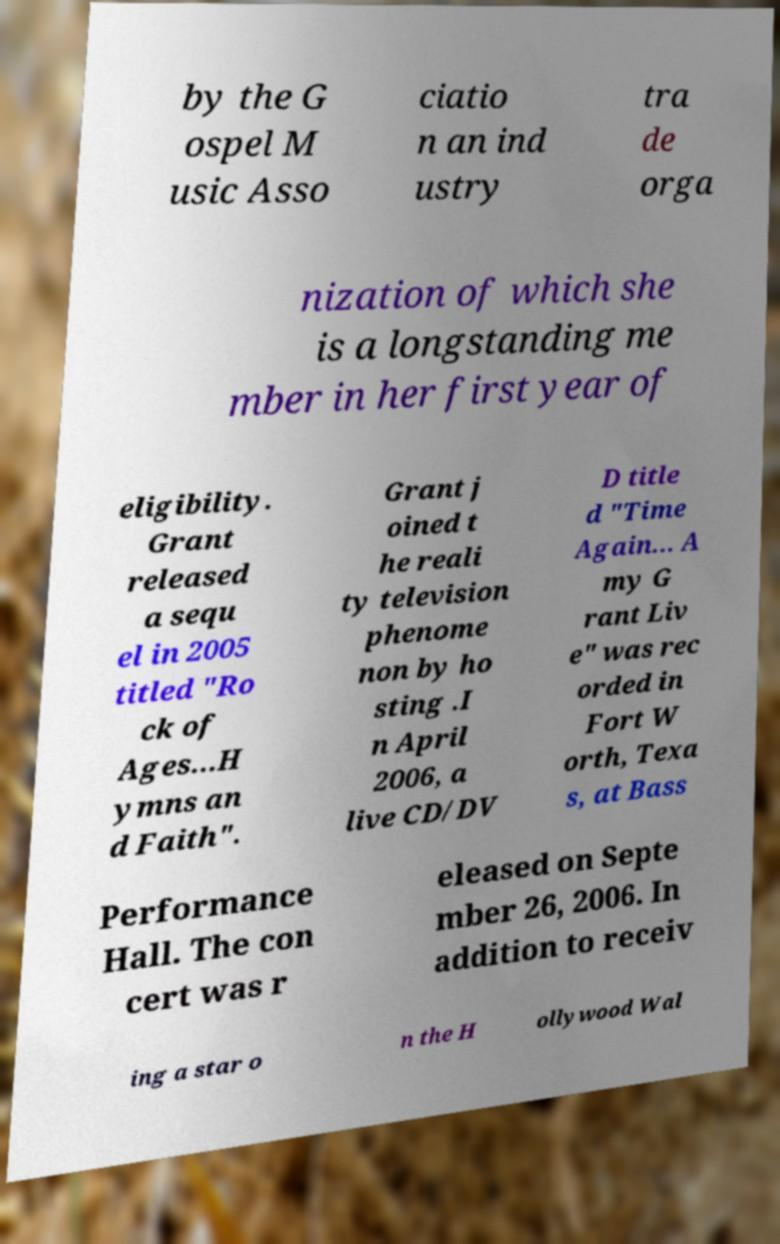Please read and relay the text visible in this image. What does it say? by the G ospel M usic Asso ciatio n an ind ustry tra de orga nization of which she is a longstanding me mber in her first year of eligibility. Grant released a sequ el in 2005 titled "Ro ck of Ages...H ymns an d Faith". Grant j oined t he reali ty television phenome non by ho sting .I n April 2006, a live CD/DV D title d "Time Again... A my G rant Liv e" was rec orded in Fort W orth, Texa s, at Bass Performance Hall. The con cert was r eleased on Septe mber 26, 2006. In addition to receiv ing a star o n the H ollywood Wal 